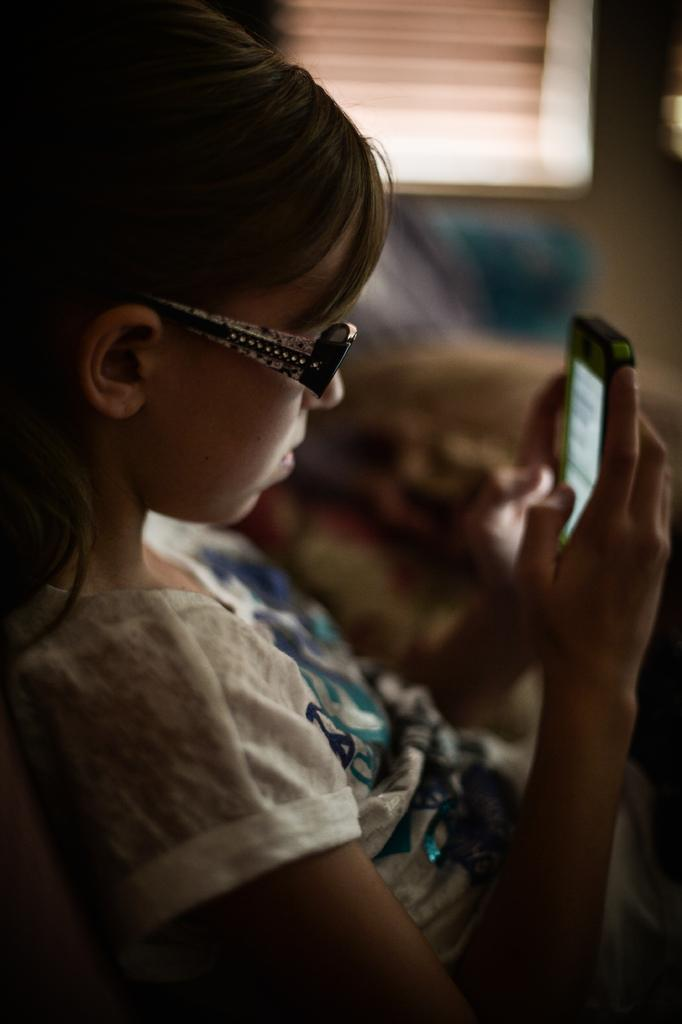Who is the main subject in the image? There is a girl in the image. Where is the girl located in the image? The girl is in the center of the image. What is the girl holding in her hands? The girl is holding a cell phone in her hands. What type of stew is the girl eating in the image? There is no stew present in the image; the girl is holding a cell phone. How does the girl contribute to world peace in the image? The image does not depict any actions related to world peace; it simply shows a girl holding a cell phone. 